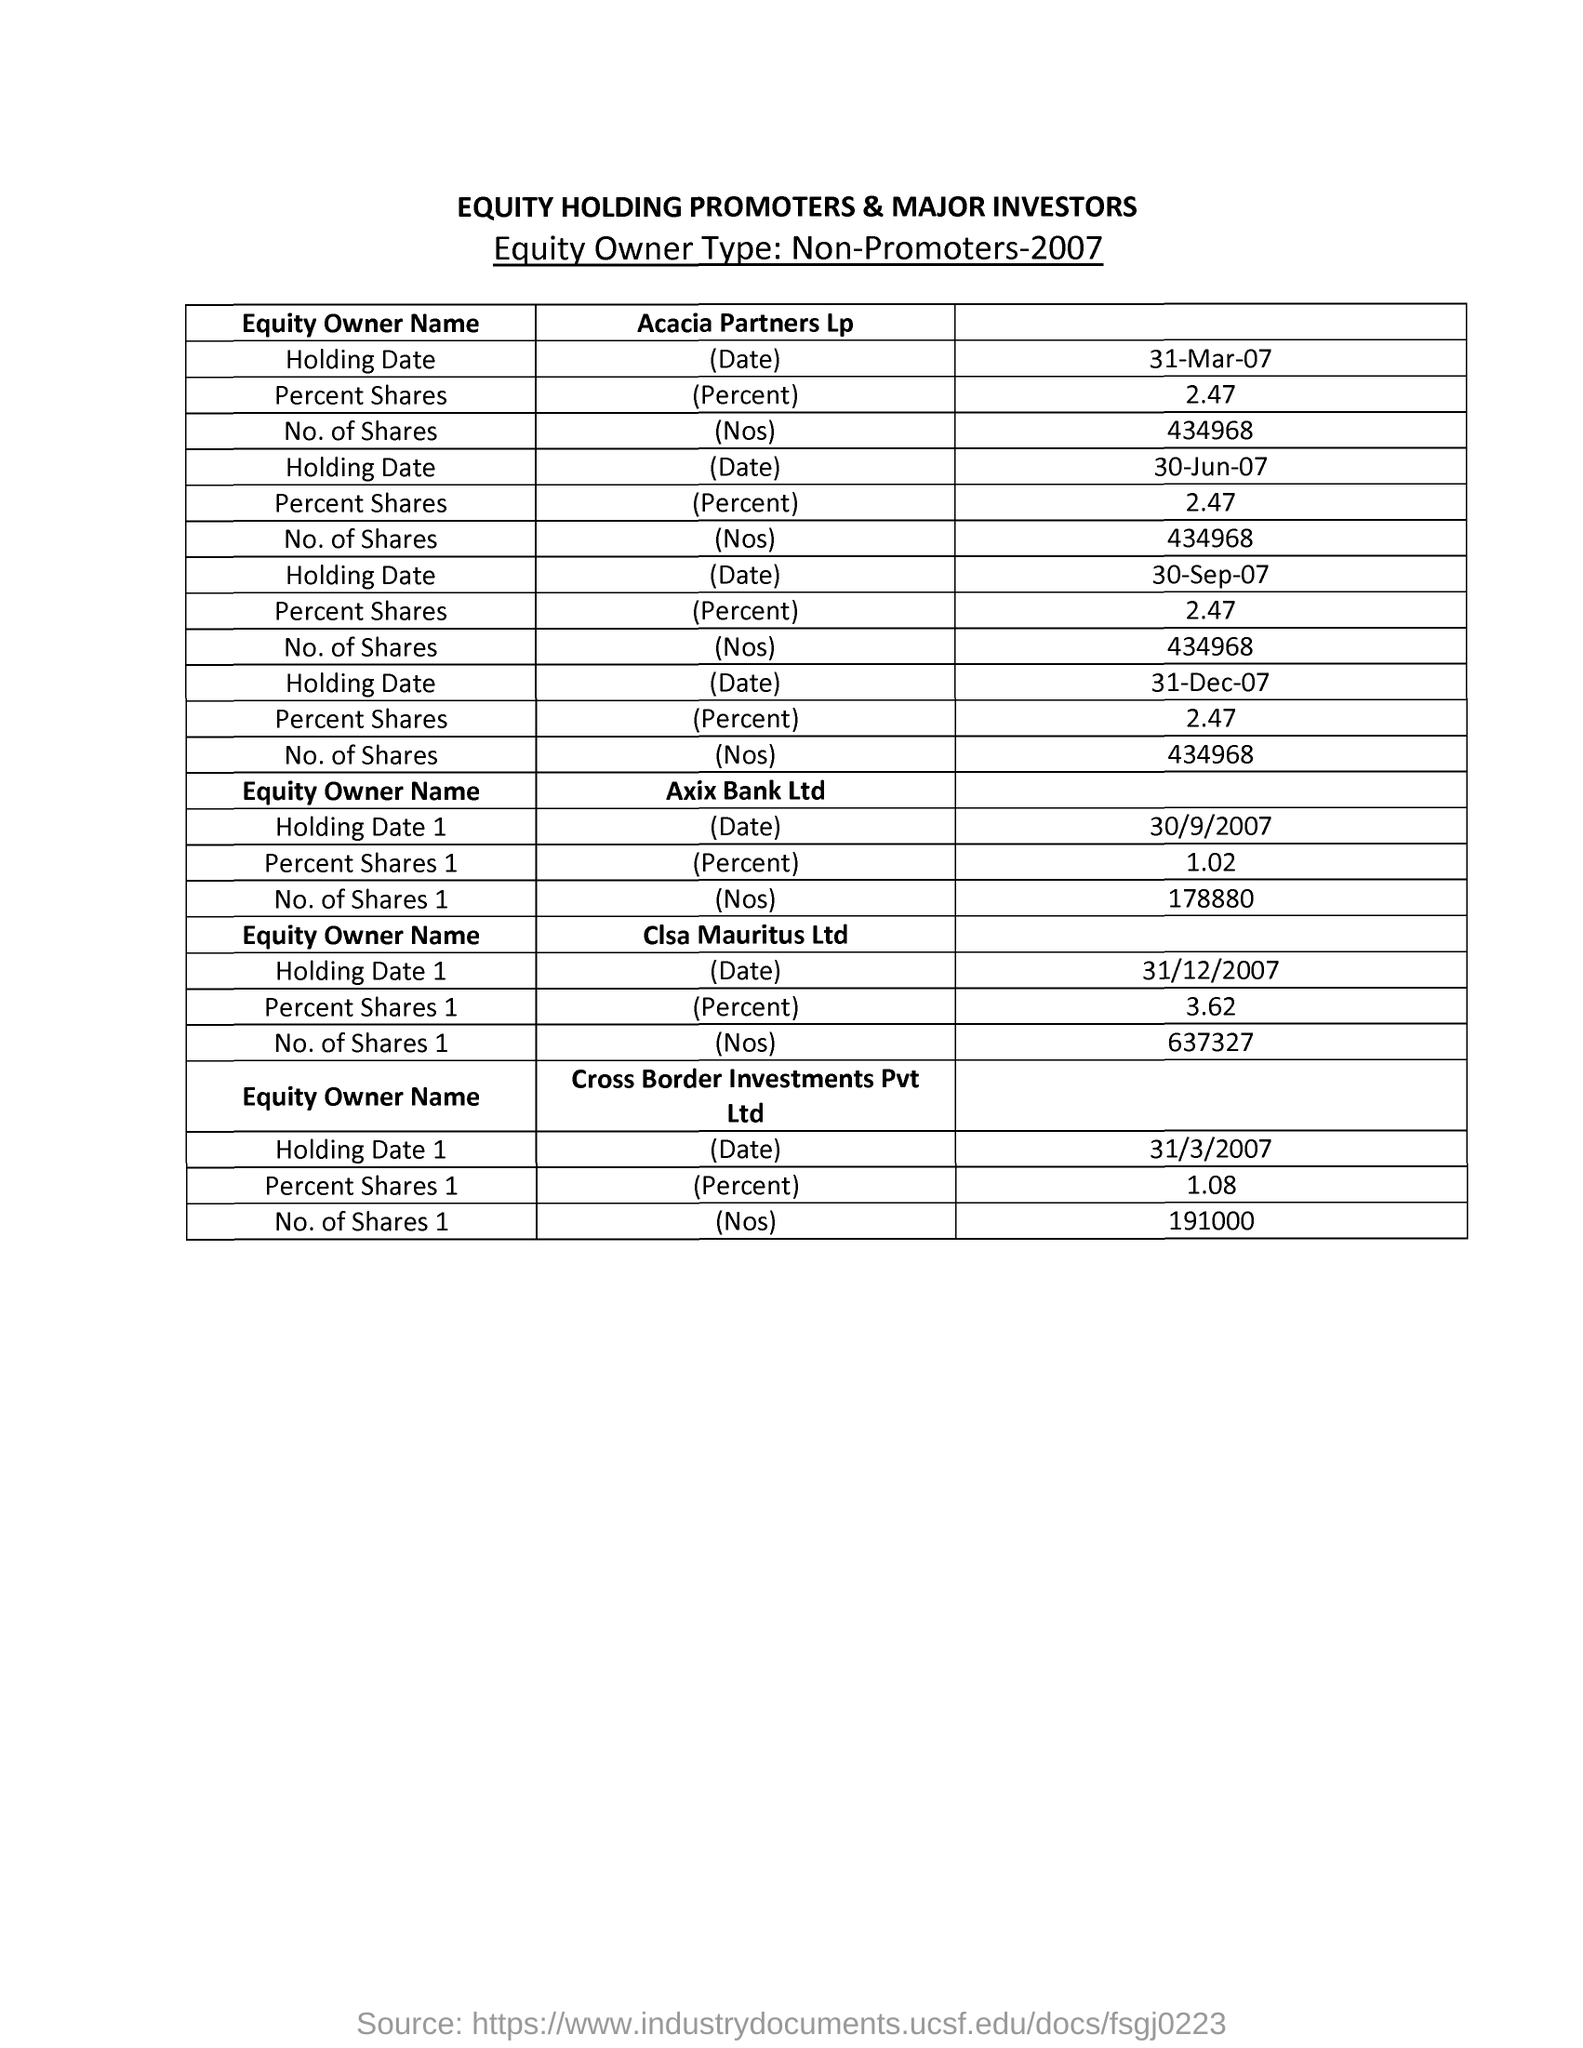Outline some significant characteristics in this image. On March 31, 2007, the percentage shares of Acacia Partners Lp were 2.47. On March 31, 2007, Cross Border Investments Pvt Ltd. held a percentage share of 1.08 of the equity of a particular entity. On the holding date of June 30, 2007, the number of shares for Acacia Partners Lp was 434,968. On December 31, 2007, Closa Mauritus Ltd. was the equity owner with the number of shares equal to 637,327. The next "Holding Date" after "30-Sep-07" of "Acacia Partners Lp" is "31-DEC-07". 